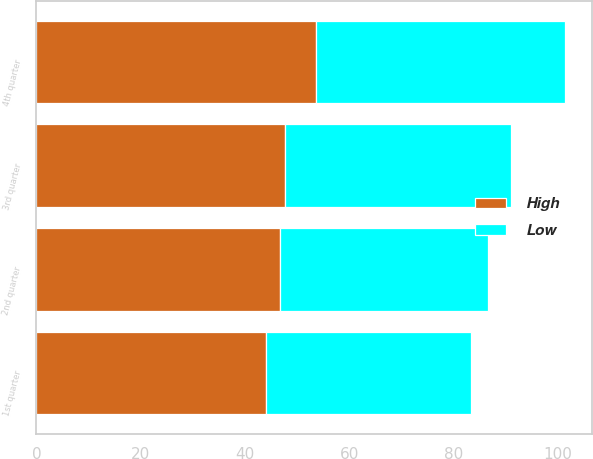Convert chart. <chart><loc_0><loc_0><loc_500><loc_500><stacked_bar_chart><ecel><fcel>1st quarter<fcel>2nd quarter<fcel>3rd quarter<fcel>4th quarter<nl><fcel>High<fcel>44.1<fcel>46.72<fcel>47.78<fcel>53.59<nl><fcel>Low<fcel>39.26<fcel>40.01<fcel>43.28<fcel>47.88<nl></chart> 